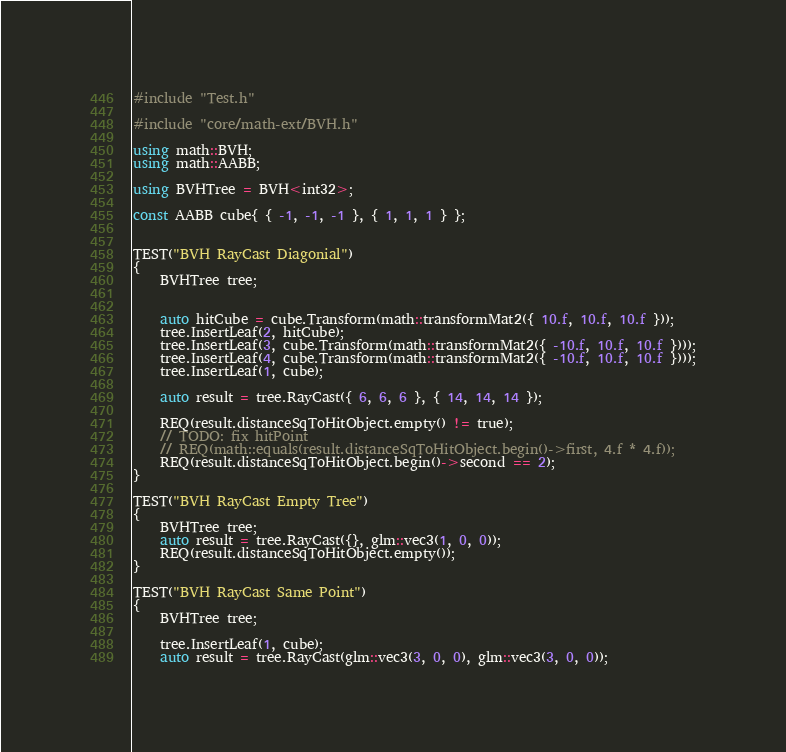<code> <loc_0><loc_0><loc_500><loc_500><_C++_>#include "Test.h"

#include "core/math-ext/BVH.h"

using math::BVH;
using math::AABB;

using BVHTree = BVH<int32>;

const AABB cube{ { -1, -1, -1 }, { 1, 1, 1 } };


TEST("BVH RayCast Diagonial")
{
	BVHTree tree;


	auto hitCube = cube.Transform(math::transformMat2({ 10.f, 10.f, 10.f }));
	tree.InsertLeaf(2, hitCube);
	tree.InsertLeaf(3, cube.Transform(math::transformMat2({ -10.f, 10.f, 10.f })));
	tree.InsertLeaf(4, cube.Transform(math::transformMat2({ -10.f, 10.f, 10.f })));
	tree.InsertLeaf(1, cube);

	auto result = tree.RayCast({ 6, 6, 6 }, { 14, 14, 14 });

	REQ(result.distanceSqToHitObject.empty() != true);
	// TODO: fix hitPoint
	// REQ(math::equals(result.distanceSqToHitObject.begin()->first, 4.f * 4.f));
	REQ(result.distanceSqToHitObject.begin()->second == 2);
}

TEST("BVH RayCast Empty Tree")
{
	BVHTree tree;
	auto result = tree.RayCast({}, glm::vec3(1, 0, 0));
	REQ(result.distanceSqToHitObject.empty());
}

TEST("BVH RayCast Same Point")
{
	BVHTree tree;

	tree.InsertLeaf(1, cube);
	auto result = tree.RayCast(glm::vec3(3, 0, 0), glm::vec3(3, 0, 0));</code> 